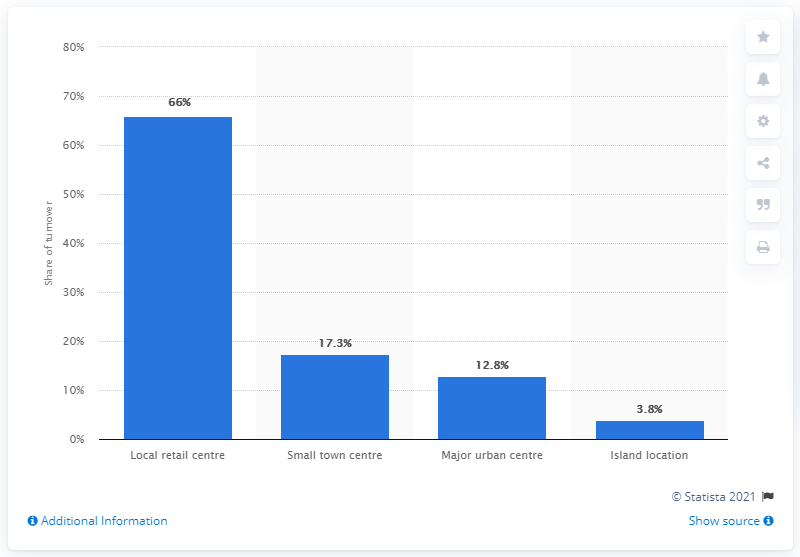List a handful of essential elements in this visual. According to a recent study, the majority of butchers' turnover is generated by local retail centers, with 66% of butchers located in these centers. 